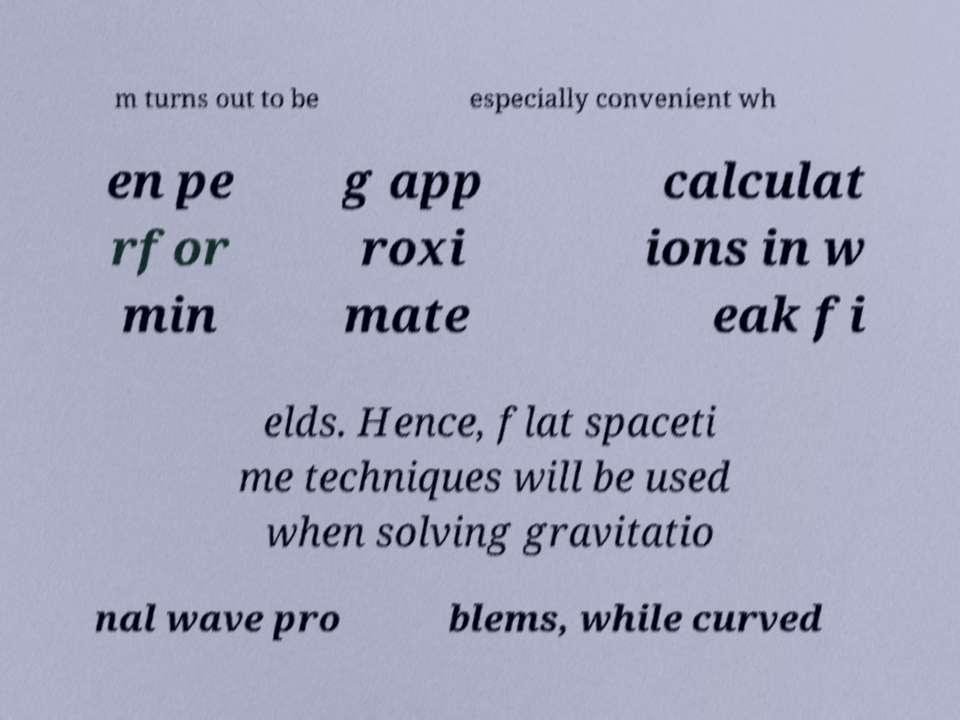For documentation purposes, I need the text within this image transcribed. Could you provide that? m turns out to be especially convenient wh en pe rfor min g app roxi mate calculat ions in w eak fi elds. Hence, flat spaceti me techniques will be used when solving gravitatio nal wave pro blems, while curved 